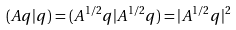Convert formula to latex. <formula><loc_0><loc_0><loc_500><loc_500>( A q | q ) = ( A ^ { 1 / 2 } q | A ^ { 1 / 2 } q ) = | A ^ { 1 / 2 } q | ^ { 2 }</formula> 